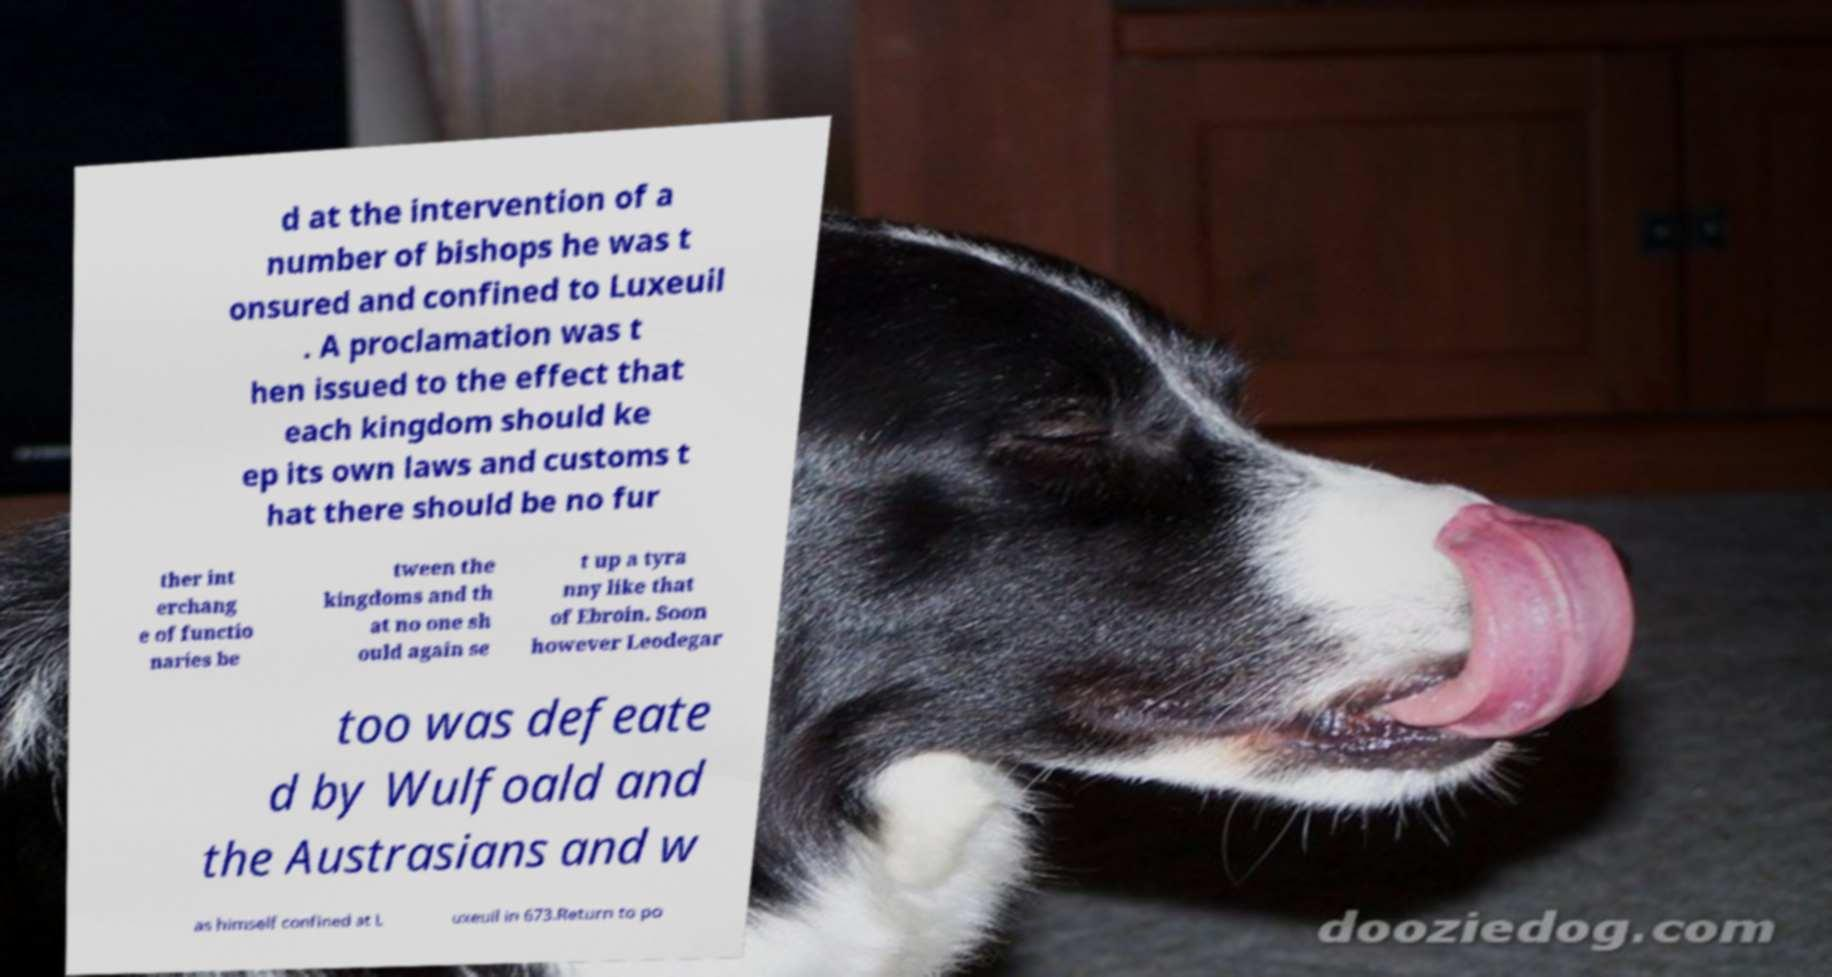Could you extract and type out the text from this image? d at the intervention of a number of bishops he was t onsured and confined to Luxeuil . A proclamation was t hen issued to the effect that each kingdom should ke ep its own laws and customs t hat there should be no fur ther int erchang e of functio naries be tween the kingdoms and th at no one sh ould again se t up a tyra nny like that of Ebroin. Soon however Leodegar too was defeate d by Wulfoald and the Austrasians and w as himself confined at L uxeuil in 673.Return to po 